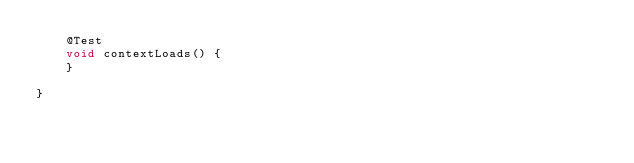<code> <loc_0><loc_0><loc_500><loc_500><_Java_>	@Test
	void contextLoads() {
	}

}
</code> 